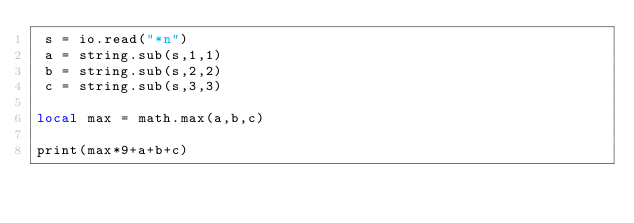Convert code to text. <code><loc_0><loc_0><loc_500><loc_500><_Lua_> s = io.read("*n")
 a = string.sub(s,1,1)
 b = string.sub(s,2,2)
 c = string.sub(s,3,3)

local max = math.max(a,b,c)

print(max*9+a+b+c)
</code> 